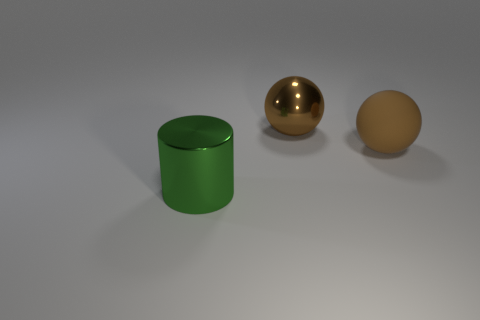Add 1 green things. How many objects exist? 4 Subtract all spheres. How many objects are left? 1 Add 3 large shiny things. How many large shiny things are left? 5 Add 2 big objects. How many big objects exist? 5 Subtract 0 cyan spheres. How many objects are left? 3 Subtract all red cylinders. Subtract all gray blocks. How many cylinders are left? 1 Subtract all big brown spheres. Subtract all big cylinders. How many objects are left? 0 